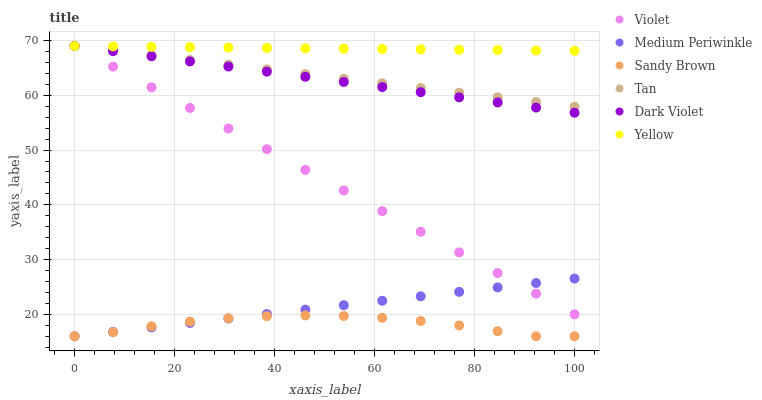Does Sandy Brown have the minimum area under the curve?
Answer yes or no. Yes. Does Yellow have the maximum area under the curve?
Answer yes or no. Yes. Does Dark Violet have the minimum area under the curve?
Answer yes or no. No. Does Dark Violet have the maximum area under the curve?
Answer yes or no. No. Is Dark Violet the smoothest?
Answer yes or no. Yes. Is Sandy Brown the roughest?
Answer yes or no. Yes. Is Yellow the smoothest?
Answer yes or no. No. Is Yellow the roughest?
Answer yes or no. No. Does Medium Periwinkle have the lowest value?
Answer yes or no. Yes. Does Dark Violet have the lowest value?
Answer yes or no. No. Does Tan have the highest value?
Answer yes or no. Yes. Does Sandy Brown have the highest value?
Answer yes or no. No. Is Sandy Brown less than Yellow?
Answer yes or no. Yes. Is Yellow greater than Medium Periwinkle?
Answer yes or no. Yes. Does Tan intersect Yellow?
Answer yes or no. Yes. Is Tan less than Yellow?
Answer yes or no. No. Is Tan greater than Yellow?
Answer yes or no. No. Does Sandy Brown intersect Yellow?
Answer yes or no. No. 